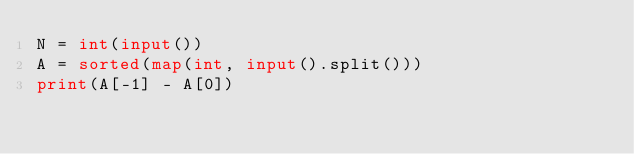Convert code to text. <code><loc_0><loc_0><loc_500><loc_500><_Python_>N = int(input())
A = sorted(map(int, input().split()))
print(A[-1] - A[0])</code> 